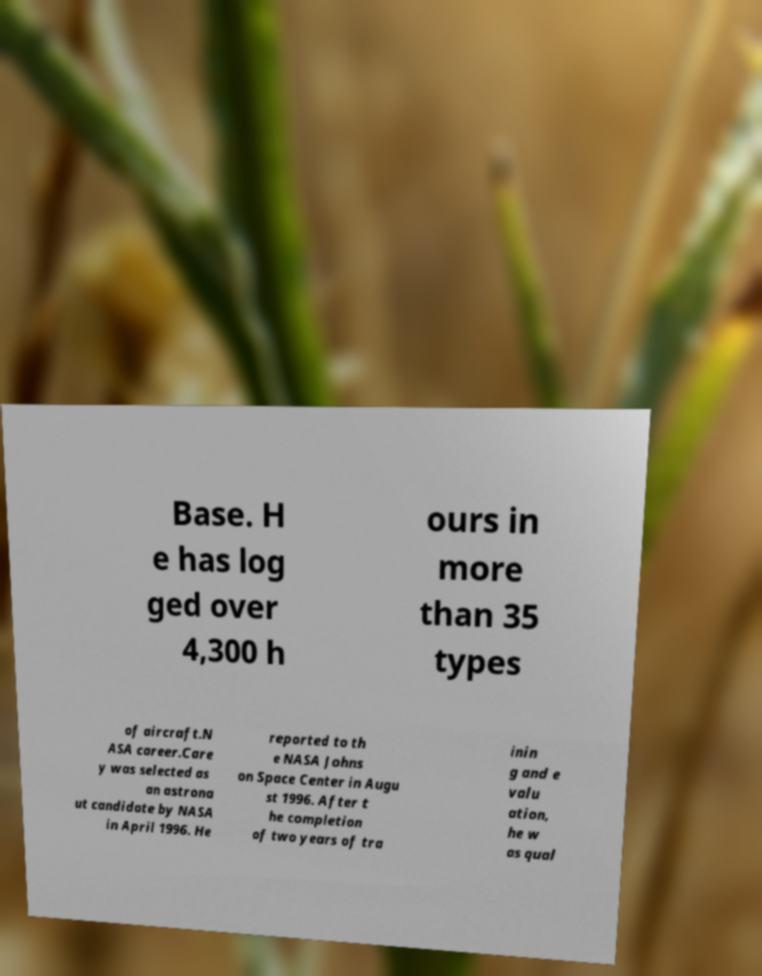There's text embedded in this image that I need extracted. Can you transcribe it verbatim? Base. H e has log ged over 4,300 h ours in more than 35 types of aircraft.N ASA career.Care y was selected as an astrona ut candidate by NASA in April 1996. He reported to th e NASA Johns on Space Center in Augu st 1996. After t he completion of two years of tra inin g and e valu ation, he w as qual 